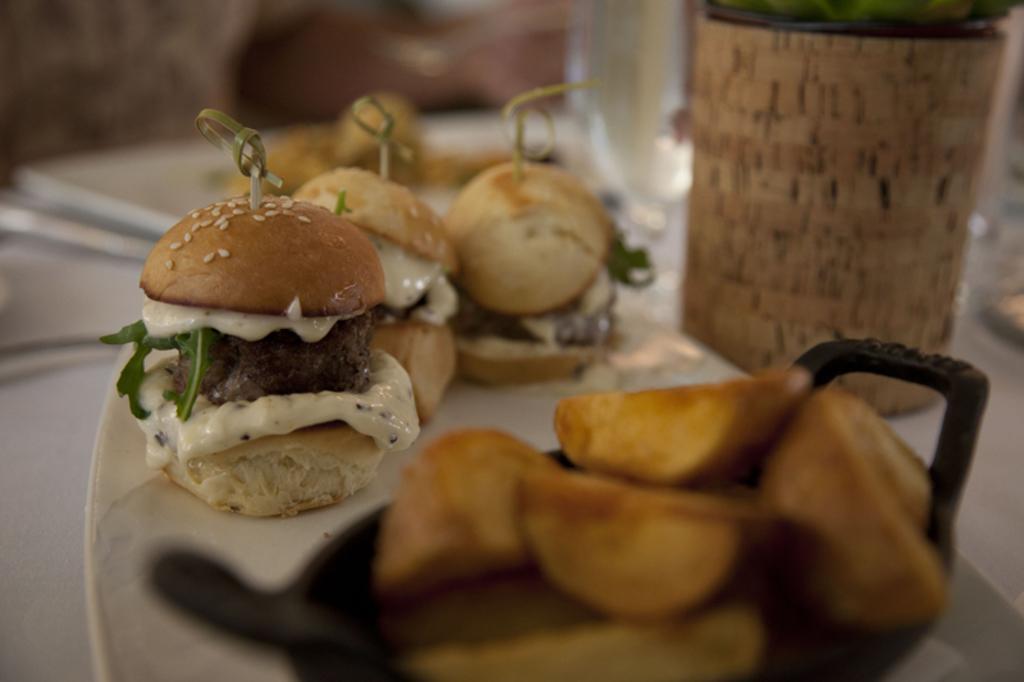How would you summarize this image in a sentence or two? In this picture we can see food in the plate, beside to the plate we can find few other things on the table. 